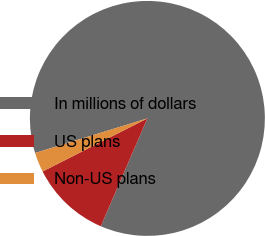Convert chart to OTSL. <chart><loc_0><loc_0><loc_500><loc_500><pie_chart><fcel>In millions of dollars<fcel>US plans<fcel>Non-US plans<nl><fcel>86.25%<fcel>11.05%<fcel>2.7%<nl></chart> 